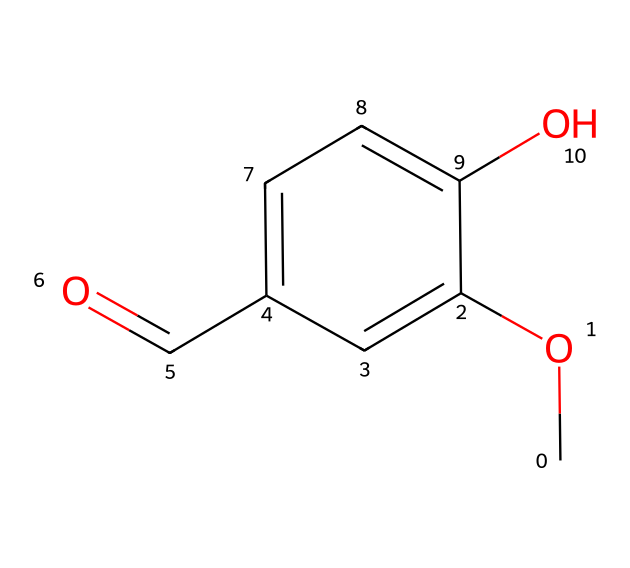What is the molecular formula of vanillin? To determine the molecular formula, we count the carbon (C), hydrogen (H), and oxygen (O) atoms in the SMILES: there are 8 carbons, 8 hydrogens, and 3 oxygens. Therefore, the molecular formula is C8H8O3.
Answer: C8H8O3 How many hydroxyl (-OH) groups are present in vanillin? Examining the chemical structure, there is one -OH group shown on the benzene ring, indicating there is one hydroxyl group in vanillin.
Answer: 1 What type of functional group is present in vanillin? The structure contains a carbonyl group (C=O) attached to a benzene ring, which classifies vanillin as an aldehyde due to the -CHO group.
Answer: aldehyde What is the total number of rings in the vanillin structure? The structure reveals a single six-membered carbon ring (the benzene ring), indicating that there is one ring present in the molecular structure of vanillin.
Answer: 1 What kind of isomerism is observed in vanillin? The presence of different functional groups and their positions on the benzene ring suggest that vanillin can exhibit positional isomerism, given the potential variations of substituents' locations on the ring.
Answer: positional isomerism How many double bonds are in the vanillin structure? In the chemical representation, there are two double bonds: one in the benzene ring and one in the carbonyl group (C=O). Thus, vanillin contains two double bonds.
Answer: 2 